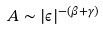<formula> <loc_0><loc_0><loc_500><loc_500>A \sim | \epsilon | ^ { - ( \beta + \gamma ) }</formula> 